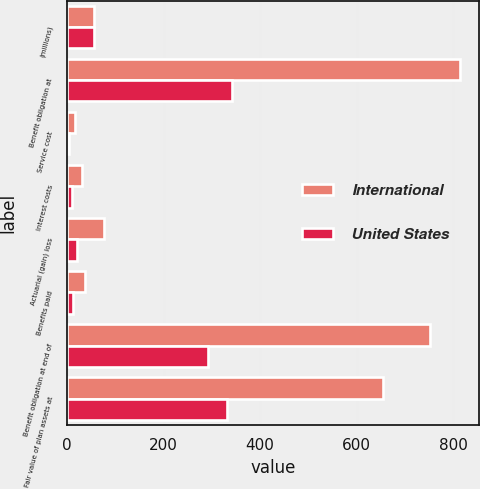Convert chart to OTSL. <chart><loc_0><loc_0><loc_500><loc_500><stacked_bar_chart><ecel><fcel>(millions)<fcel>Benefit obligation at<fcel>Service cost<fcel>Interest costs<fcel>Actuarial (gain) loss<fcel>Benefits paid<fcel>Benefit obligation at end of<fcel>Fair value of plan assets at<nl><fcel>International<fcel>56.25<fcel>813.7<fcel>17<fcel>31.6<fcel>76.2<fcel>36.3<fcel>752.6<fcel>654.2<nl><fcel>United States<fcel>56.25<fcel>341.5<fcel>4.3<fcel>9.2<fcel>20.2<fcel>13.2<fcel>292.9<fcel>331.3<nl></chart> 